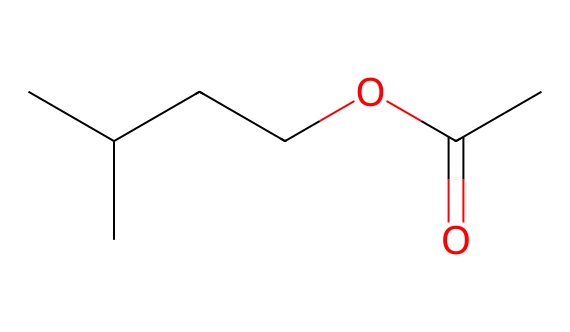What is the molecular formula of this chemical? By analyzing the SMILES representation, "CC(C)CCOC(=O)C", we can break it down: "CC(C)" indicates a branched carbon chain with 5 carbon atoms, "CC" indicates 2 more adding up to a total of 7 carbons. The "OC(=O)" denotes one oxygen connected to a carbonyl group. Therefore, we can summarize the molecule's composition as C7H14O2 by counting all the hydrogen and oxygen atoms associated with those carbons.
Answer: C7H14O2 How many carbon atoms are present in this structure? In the SMILES representation "CC(C)CCOC(=O)C", we identify each letter "C" corresponds to a carbon atom. From the breakdown—CC(C) gives 5 C's, CC gives 2 C's, and there’s one more C in the carbonyl, totaling 7 carbon atoms.
Answer: 7 What type of functional group is present in this chemical? The SMILES "CC(C)CCOC(=O)C" contains "OC(=O)" which signifies an ester functional group. The "C(=O)" indicates a carbonyl connected to the oxygen, defining it as an ester upon connecting with another carbon chain.
Answer: ester Is this chemical likely to be flammable? The presence of multiple carbon atoms and the ester functional group suggests that it is organic and volatile. Given that esters are generally flammable, as well as the branched nature of the carbon structure which typically contributes to lower flash points, we can conclude that this chemical likely has flammable properties.
Answer: yes What is the common use of isoamyl acetate in wines? Isoamyl acetate is a volatile compound most commonly associated with banana and pear flavors, contributing significant aroma qualities to wine. Its distinct fruity note enhances the overall perception of the wine's bouquet, especially in certain varietals.
Answer: aroma enhancer How does the branching in the carbon chain affect the volatility of this compound? The branching in the carbon chain reduces the surface area compared to straight-chain alkanes, typically leading to decreased intermolecular forces. This results in increased volatility and lower boiling points, which means that isoamyl acetate will evaporate more easily, enhancing its aroma profile in wines.
Answer: increases volatility 